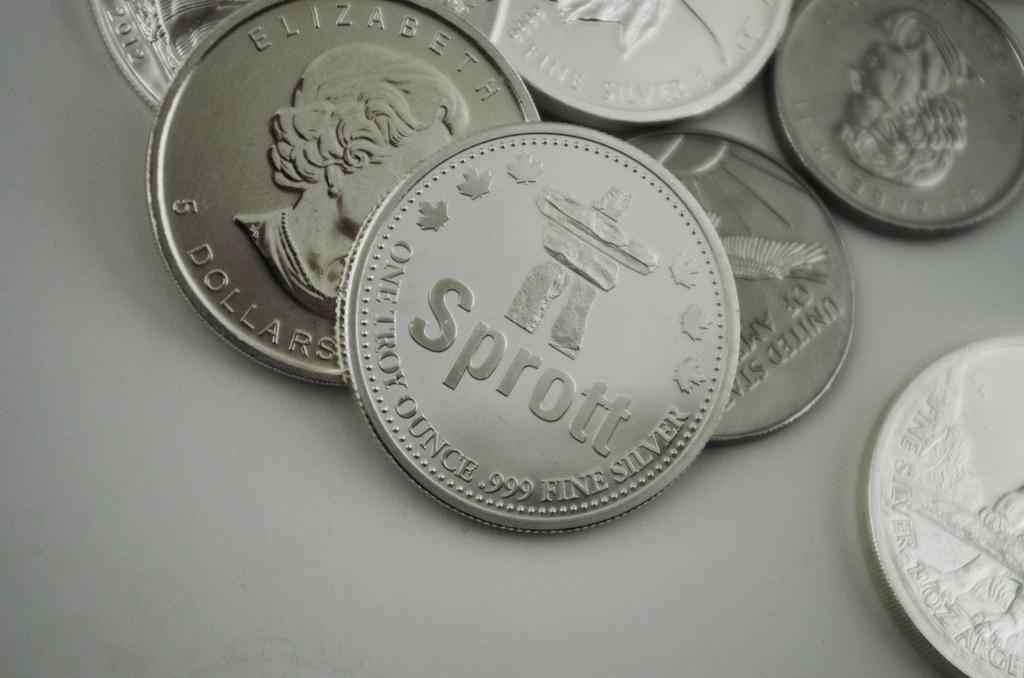<image>
Create a compact narrative representing the image presented. Many silver coins on a table including one that says Sprott on it. 